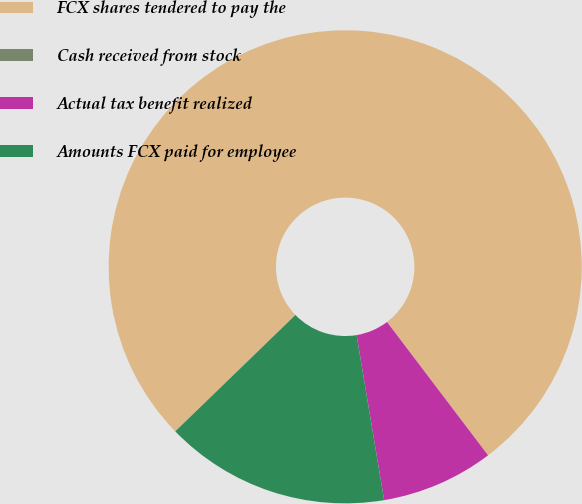Convert chart. <chart><loc_0><loc_0><loc_500><loc_500><pie_chart><fcel>FCX shares tendered to pay the<fcel>Cash received from stock<fcel>Actual tax benefit realized<fcel>Amounts FCX paid for employee<nl><fcel>76.92%<fcel>0.0%<fcel>7.69%<fcel>15.39%<nl></chart> 